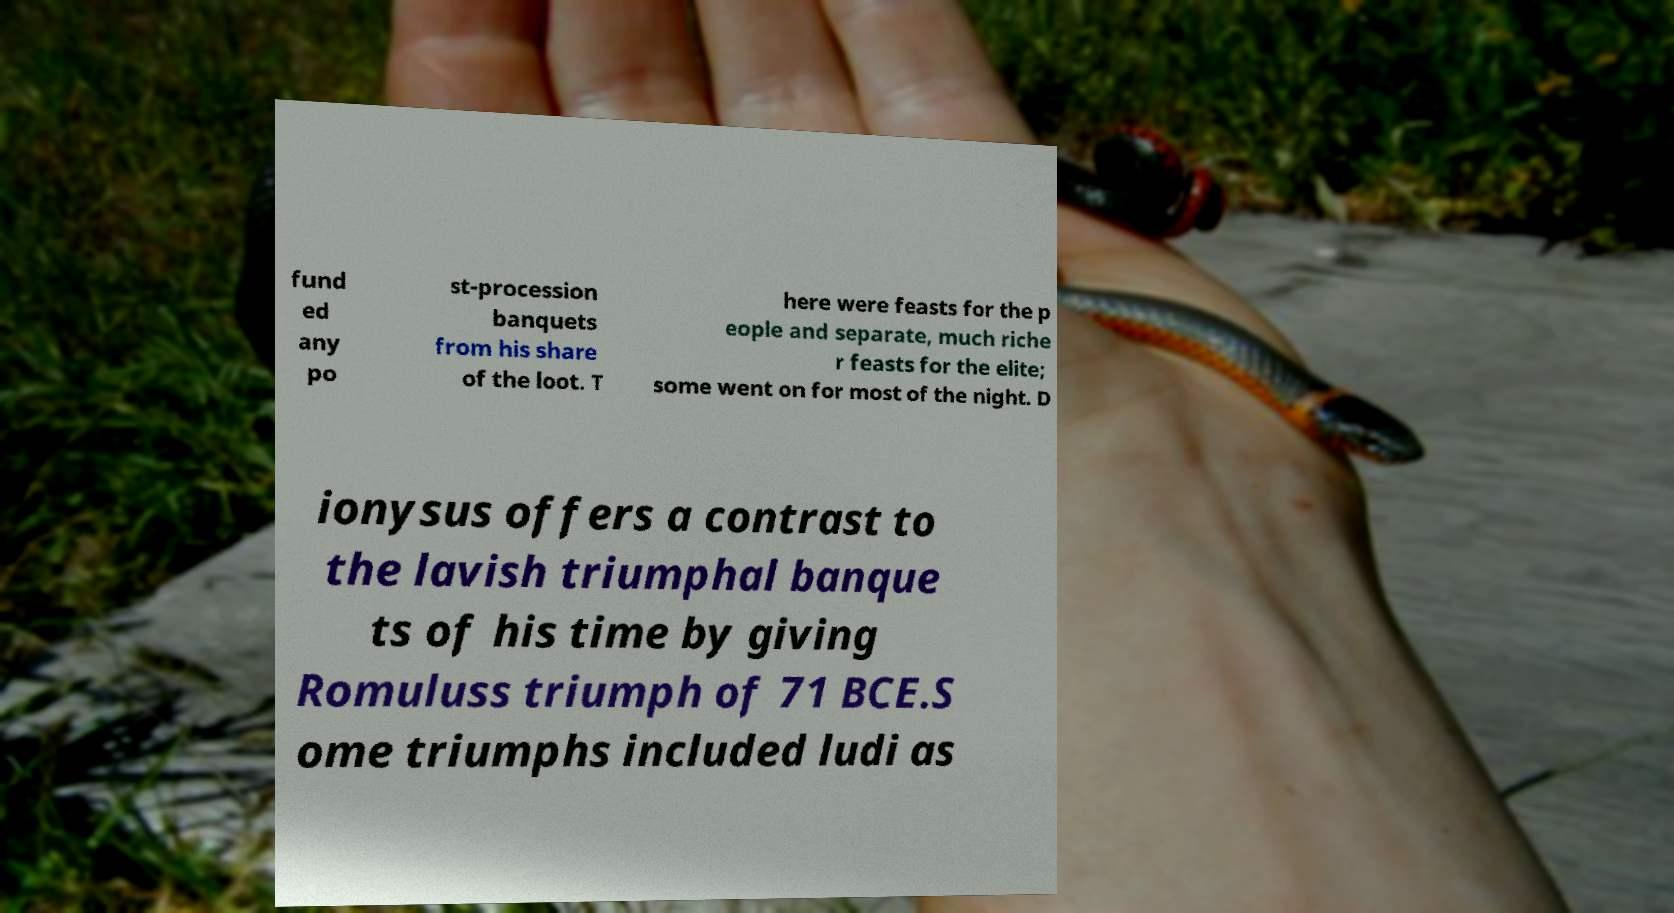Please read and relay the text visible in this image. What does it say? fund ed any po st-procession banquets from his share of the loot. T here were feasts for the p eople and separate, much riche r feasts for the elite; some went on for most of the night. D ionysus offers a contrast to the lavish triumphal banque ts of his time by giving Romuluss triumph of 71 BCE.S ome triumphs included ludi as 